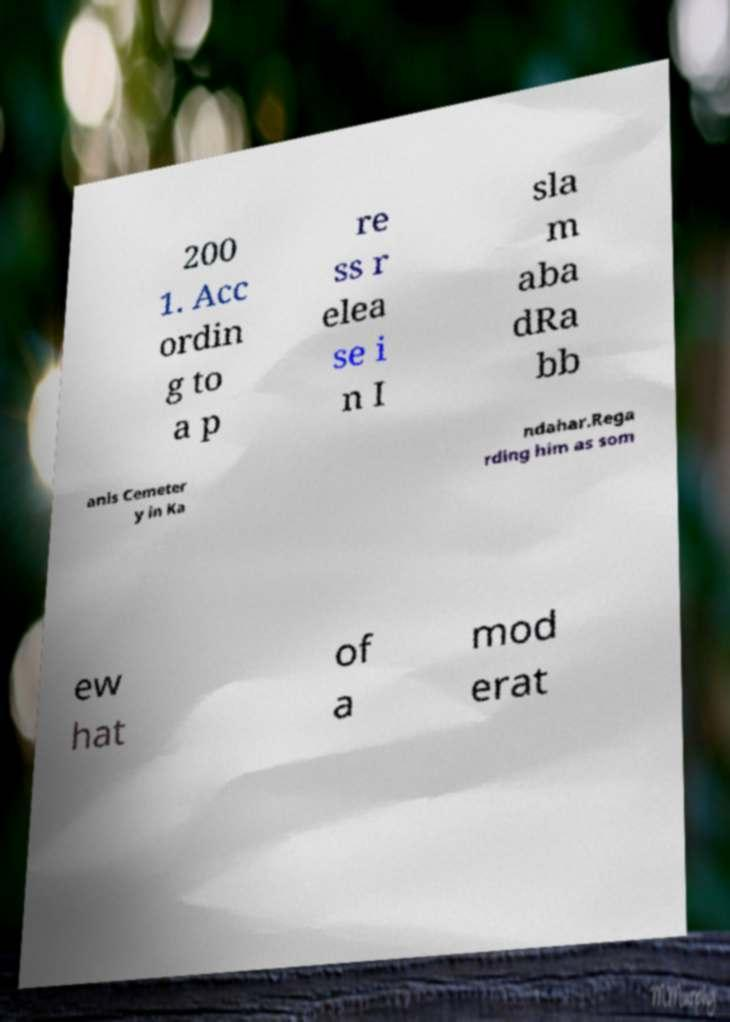Can you read and provide the text displayed in the image?This photo seems to have some interesting text. Can you extract and type it out for me? 200 1. Acc ordin g to a p re ss r elea se i n I sla m aba dRa bb anis Cemeter y in Ka ndahar.Rega rding him as som ew hat of a mod erat 